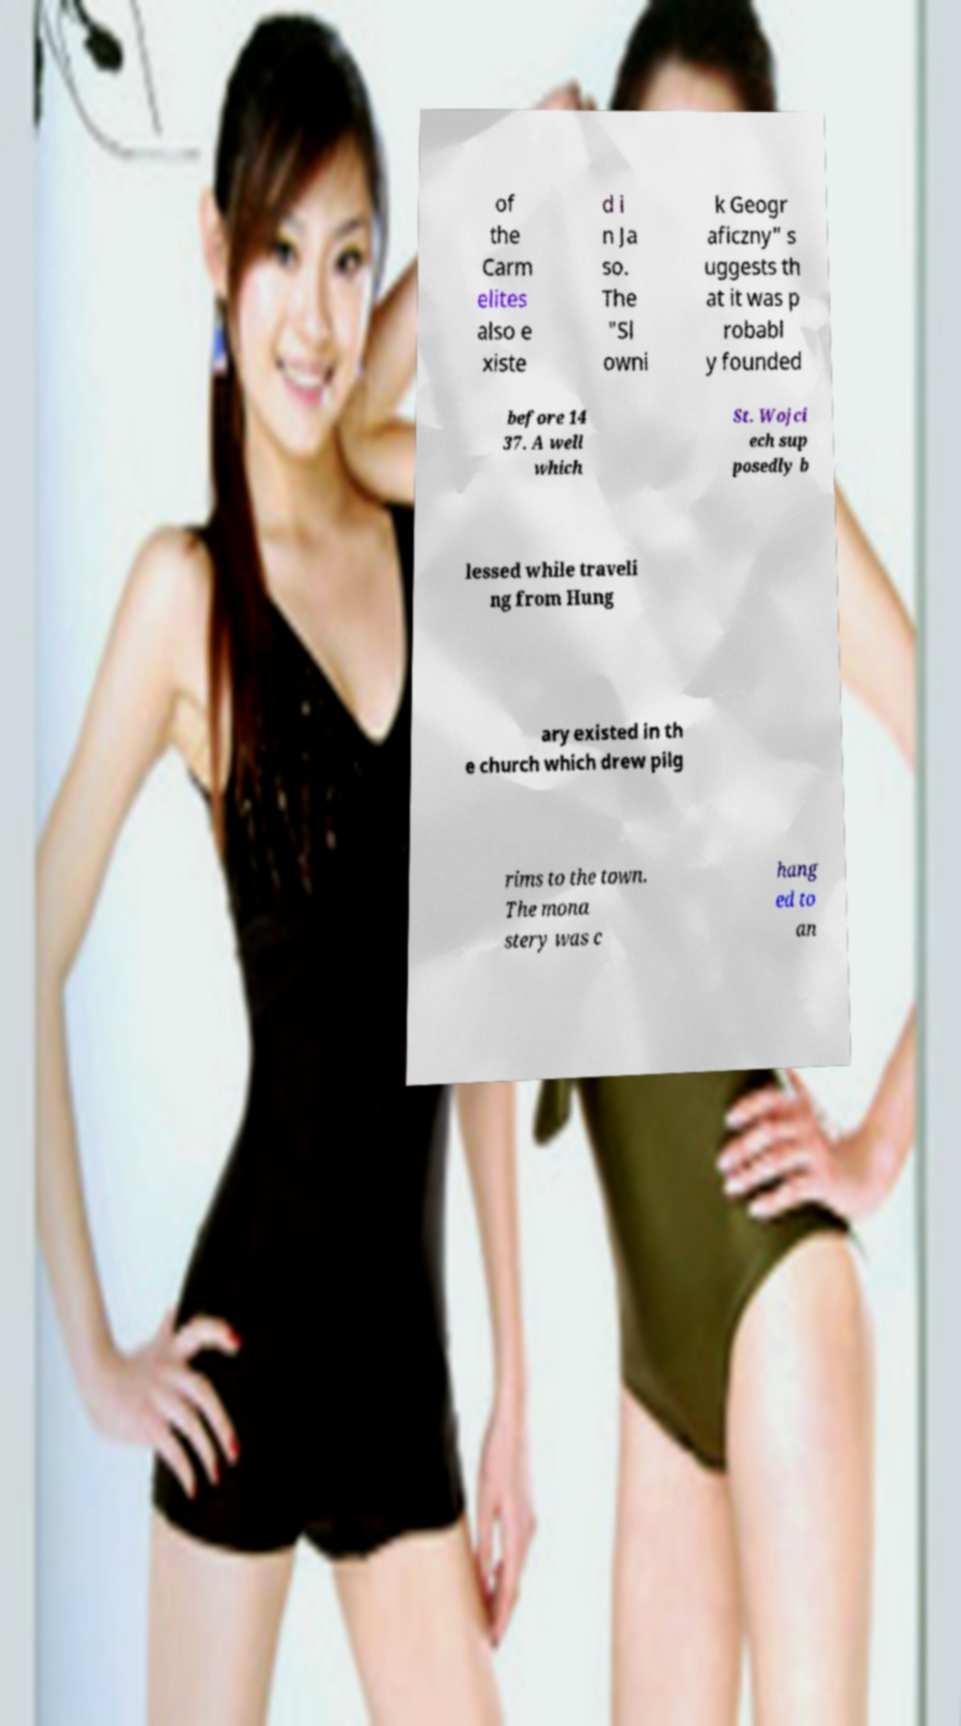Could you assist in decoding the text presented in this image and type it out clearly? of the Carm elites also e xiste d i n Ja so. The "Sl owni k Geogr aficzny" s uggests th at it was p robabl y founded before 14 37. A well which St. Wojci ech sup posedly b lessed while traveli ng from Hung ary existed in th e church which drew pilg rims to the town. The mona stery was c hang ed to an 